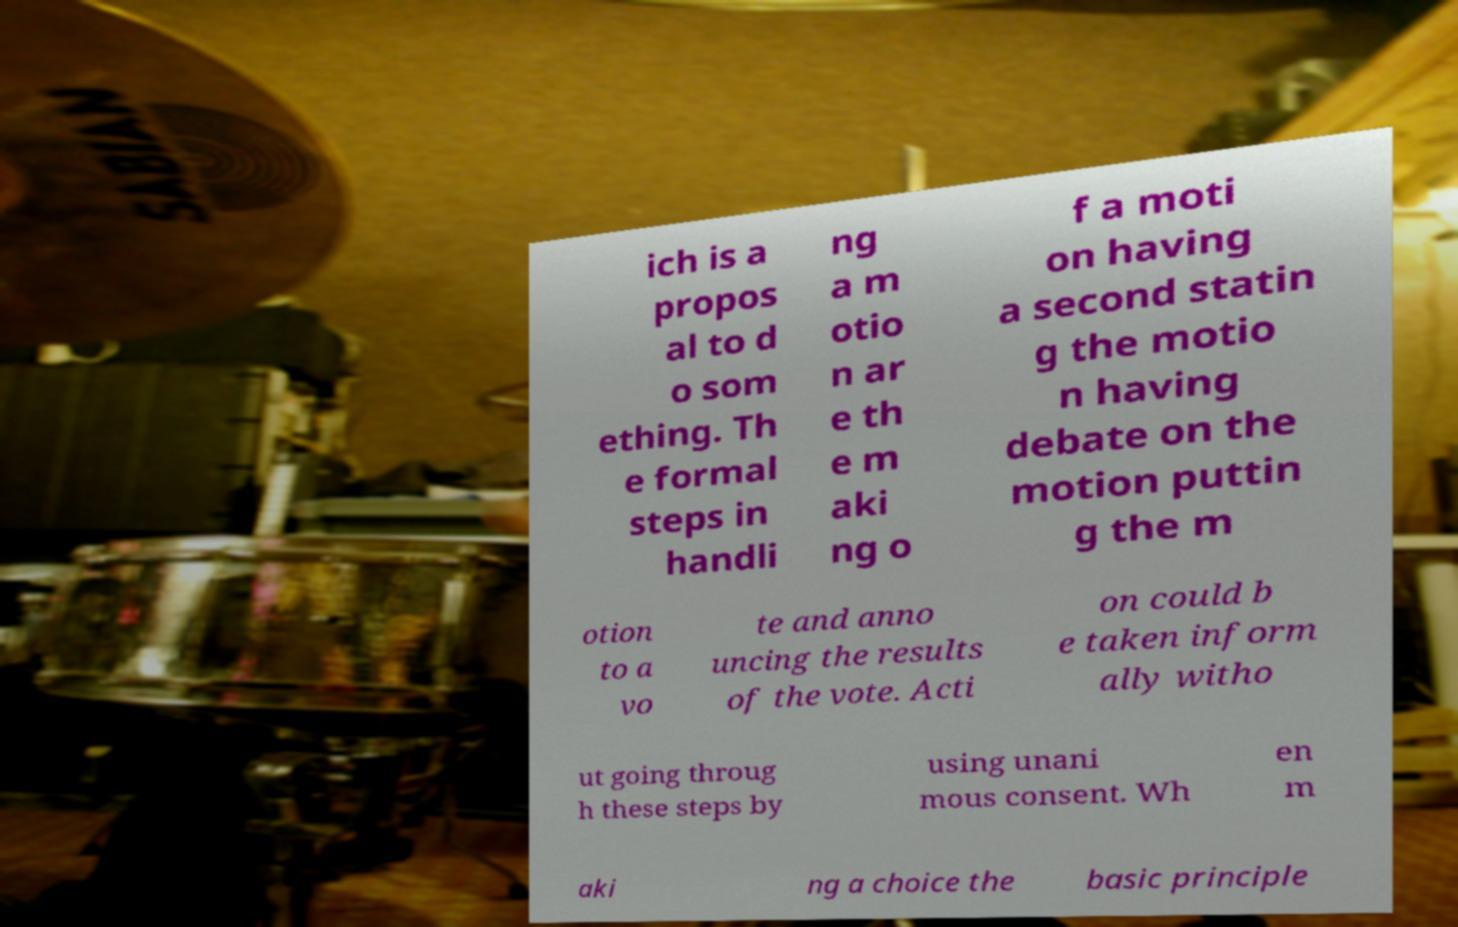What messages or text are displayed in this image? I need them in a readable, typed format. ich is a propos al to d o som ething. Th e formal steps in handli ng a m otio n ar e th e m aki ng o f a moti on having a second statin g the motio n having debate on the motion puttin g the m otion to a vo te and anno uncing the results of the vote. Acti on could b e taken inform ally witho ut going throug h these steps by using unani mous consent. Wh en m aki ng a choice the basic principle 